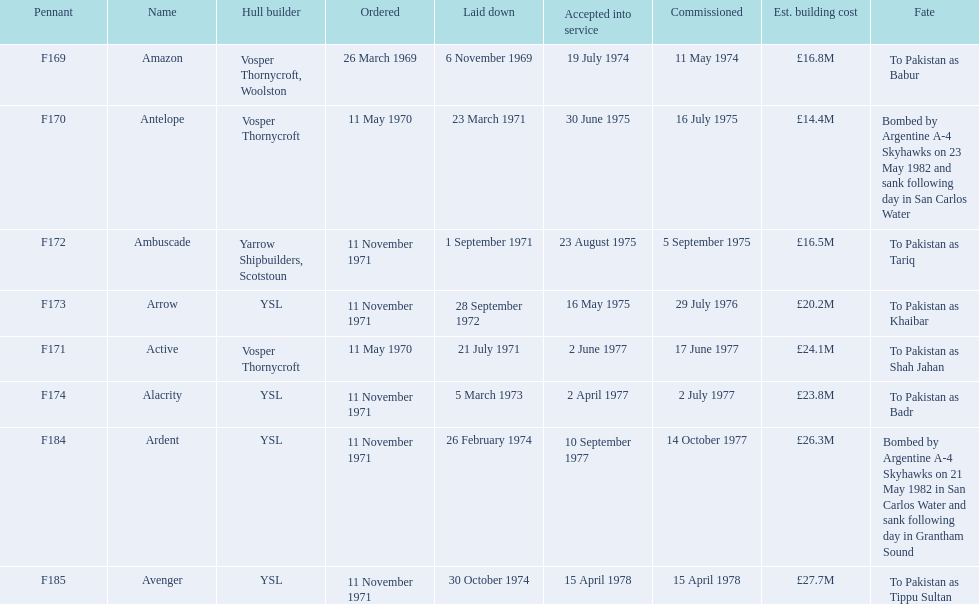How many boats had a building expense below £20m? 3. 